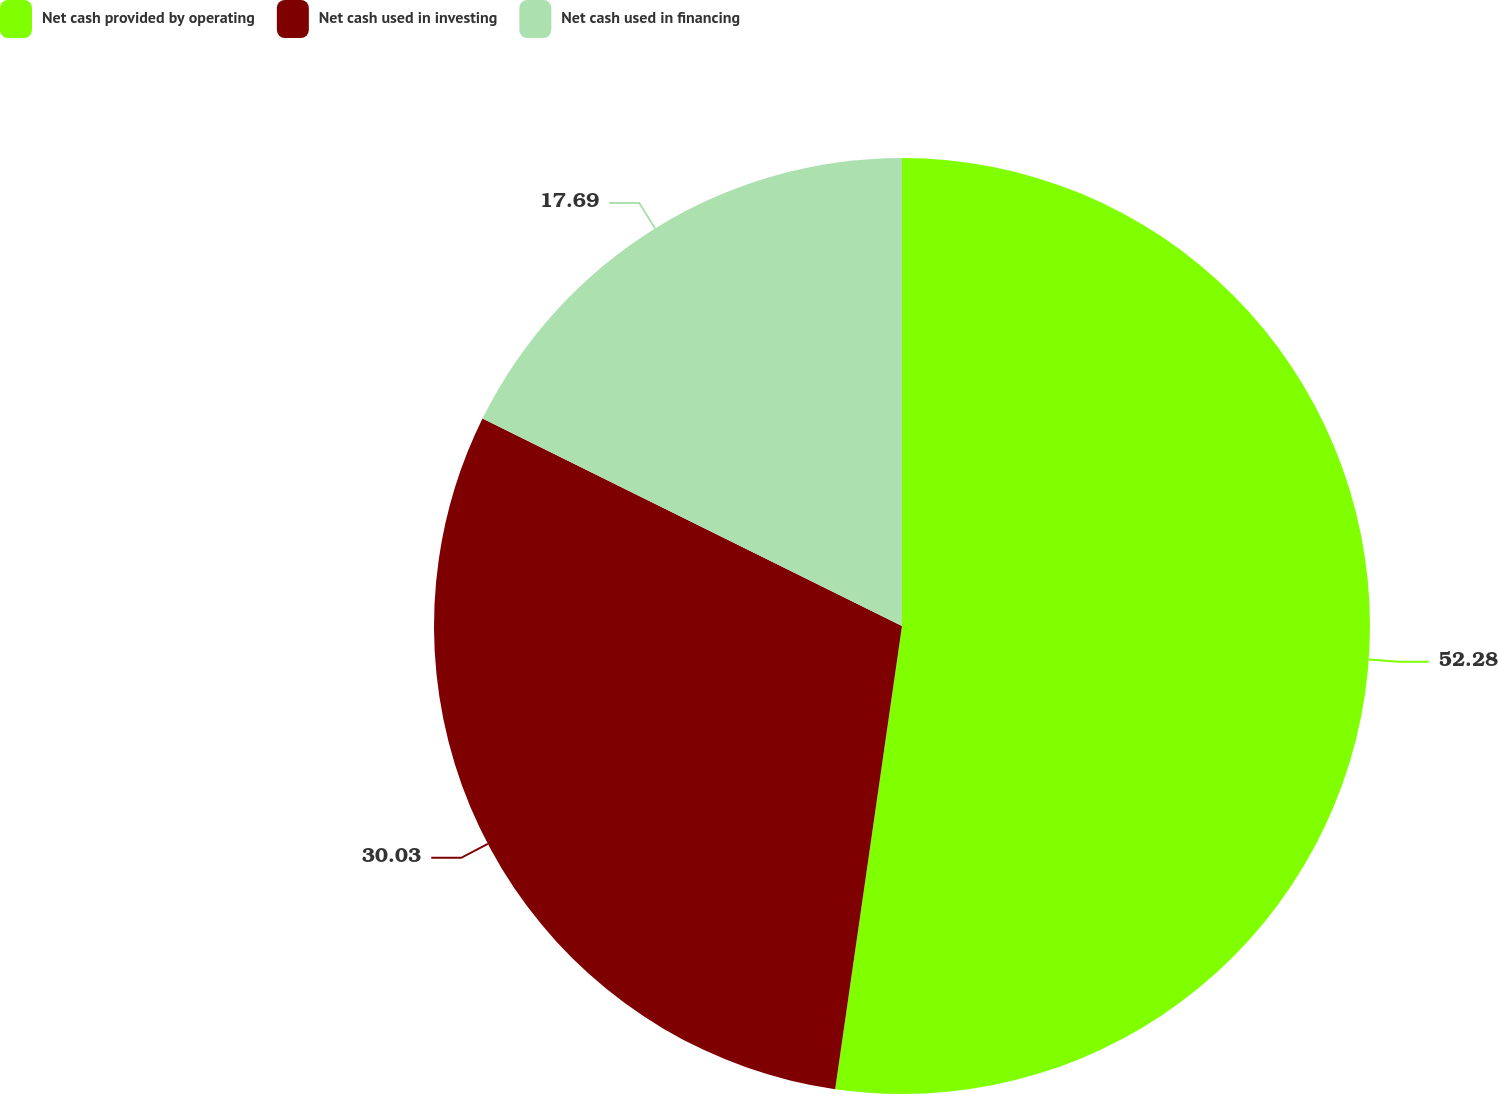Convert chart to OTSL. <chart><loc_0><loc_0><loc_500><loc_500><pie_chart><fcel>Net cash provided by operating<fcel>Net cash used in investing<fcel>Net cash used in financing<nl><fcel>52.28%<fcel>30.03%<fcel>17.69%<nl></chart> 